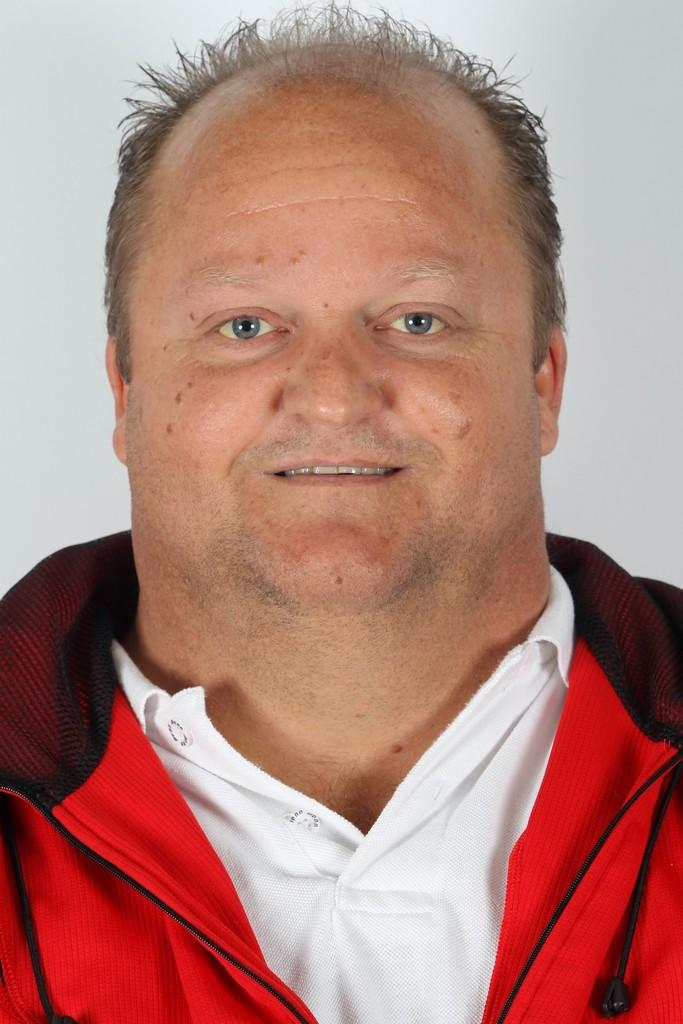What is present in the image? There is a person in the image. How is the person's expression? The person is smiling. What can be seen behind the person? There is a wall behind the person. What type of skate is the fireman using in the image? There is no fireman or skate present in the image. Is the actor in the image performing a scene from a play? There is no actor or indication of a performance in the image. 